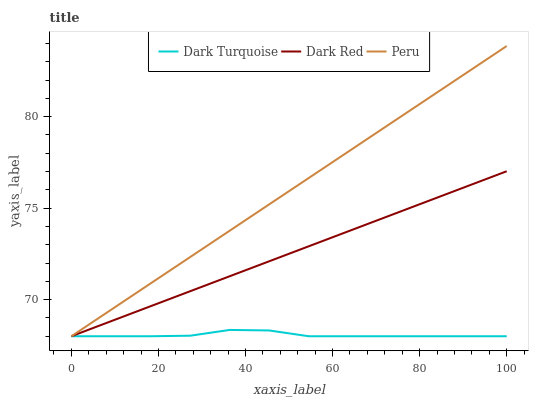Does Dark Turquoise have the minimum area under the curve?
Answer yes or no. Yes. Does Peru have the maximum area under the curve?
Answer yes or no. Yes. Does Dark Red have the minimum area under the curve?
Answer yes or no. No. Does Dark Red have the maximum area under the curve?
Answer yes or no. No. Is Dark Red the smoothest?
Answer yes or no. Yes. Is Dark Turquoise the roughest?
Answer yes or no. Yes. Is Peru the smoothest?
Answer yes or no. No. Is Peru the roughest?
Answer yes or no. No. Does Dark Turquoise have the lowest value?
Answer yes or no. Yes. Does Peru have the highest value?
Answer yes or no. Yes. Does Dark Red have the highest value?
Answer yes or no. No. Does Dark Turquoise intersect Peru?
Answer yes or no. Yes. Is Dark Turquoise less than Peru?
Answer yes or no. No. Is Dark Turquoise greater than Peru?
Answer yes or no. No. 